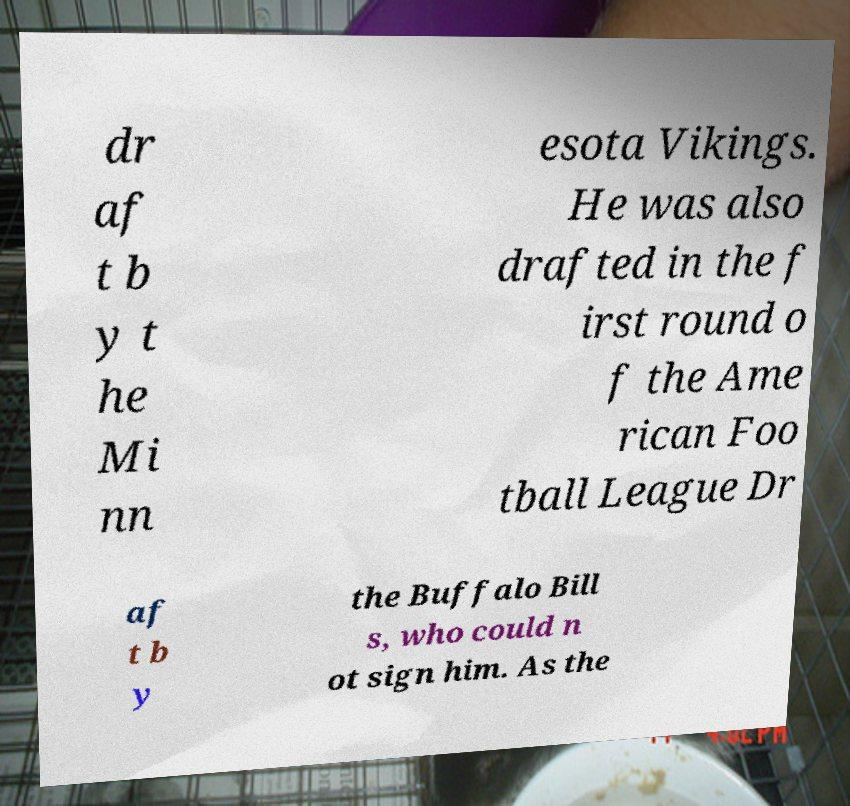Can you read and provide the text displayed in the image?This photo seems to have some interesting text. Can you extract and type it out for me? dr af t b y t he Mi nn esota Vikings. He was also drafted in the f irst round o f the Ame rican Foo tball League Dr af t b y the Buffalo Bill s, who could n ot sign him. As the 